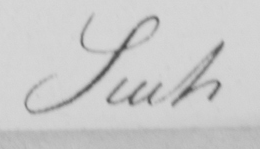What does this handwritten line say? Such 